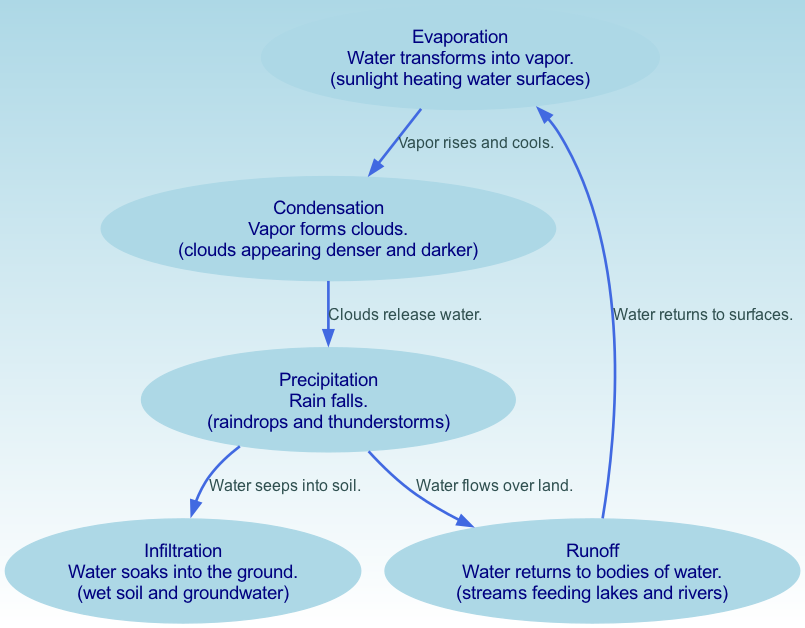What is the first process in the water cycle shown in the diagram? The diagram lists "Evaporation" as the first node, indicating the initial stage where water transforms into vapor.
Answer: Evaporation How many edges are present in the diagram? By counting the edges represented in the diagram, there are a total of five edges connecting the nodes.
Answer: 5 What happens to water after "Precipitation"? After "Precipitation", the diagram shows that water can either flow over land as "Runoff" or seep into the ground as "Infiltration".
Answer: Runoff or Infiltration What does "Condensation" describe in the diagram? The diagram describes "Condensation" as the process where vapor forms clouds, characterized by denser and darker clouds appearing.
Answer: Vapor forms clouds What transition occurs between "Evaporation" and "Condensation"? The edge from "Evaporation" to "Condensation" is described as "Vapor rises and cools," indicating the transformation stage in the water cycle.
Answer: Vapor rises and cools Which node represents the release of water from clouds? The node "Precipitation" specifically represents the stage where clouds release water in the form of rain.
Answer: Precipitation How does water return to bodies of water according to the diagram? Water returns to bodies of water from "Runoff", which describes the process of water flowing over land into lakes and rivers.
Answer: Runoff What visual representation is associated with "Infiltration"? The diagram visually represents "Infiltration" with imagery of wet soil and groundwater, emphasizing the absorption of water into the ground.
Answer: Wet soil and groundwater What is the significance of the line connecting "Precipitation" to "Infiltration"? The edge connecting these nodes indicates that after rain falls (precipitation), the water can seep into the soil, highlighting an important part of the water cycle.
Answer: Water seeps into soil 